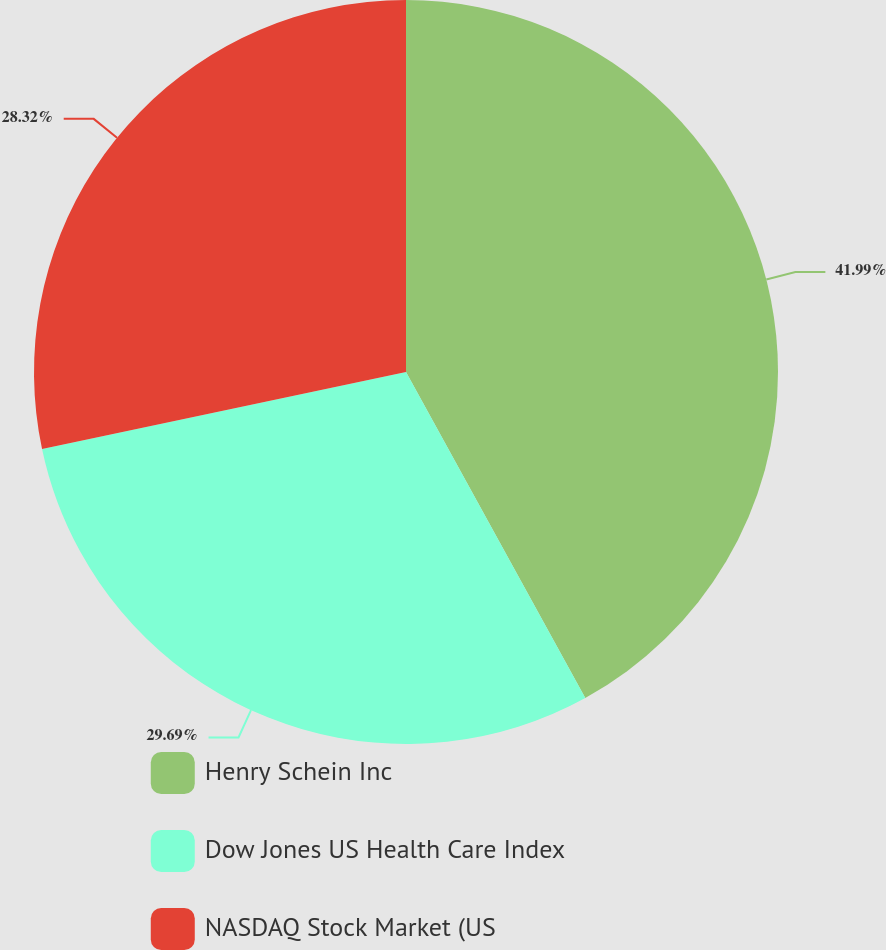<chart> <loc_0><loc_0><loc_500><loc_500><pie_chart><fcel>Henry Schein Inc<fcel>Dow Jones US Health Care Index<fcel>NASDAQ Stock Market (US<nl><fcel>42.0%<fcel>29.69%<fcel>28.32%<nl></chart> 